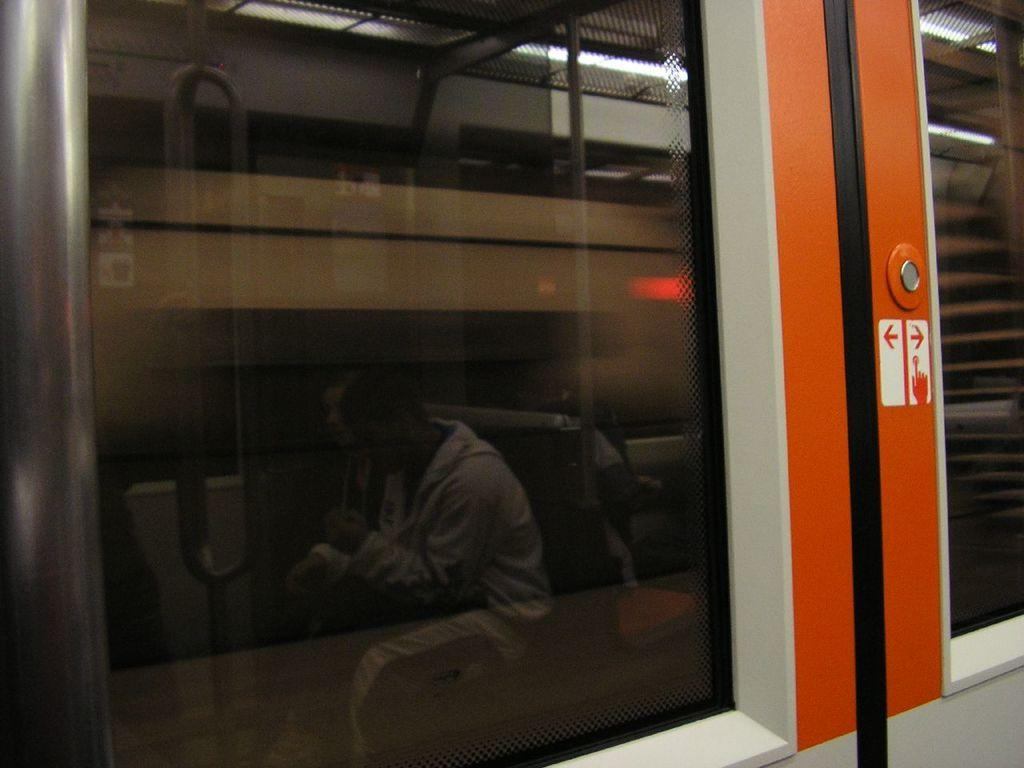What can be seen through the windows in the image? People are visible through the windows in the image. What are the people doing in the scene? The people are sitting on chairs. What other objects can be seen in the image? Poles and lights are present in the scene. What type of bells can be heard ringing in the image? There are no bells present in the image, and therefore no sounds can be heard. What are the people learning in the image? The image does not provide information about what the people are learning, as it only shows them sitting on chairs. 